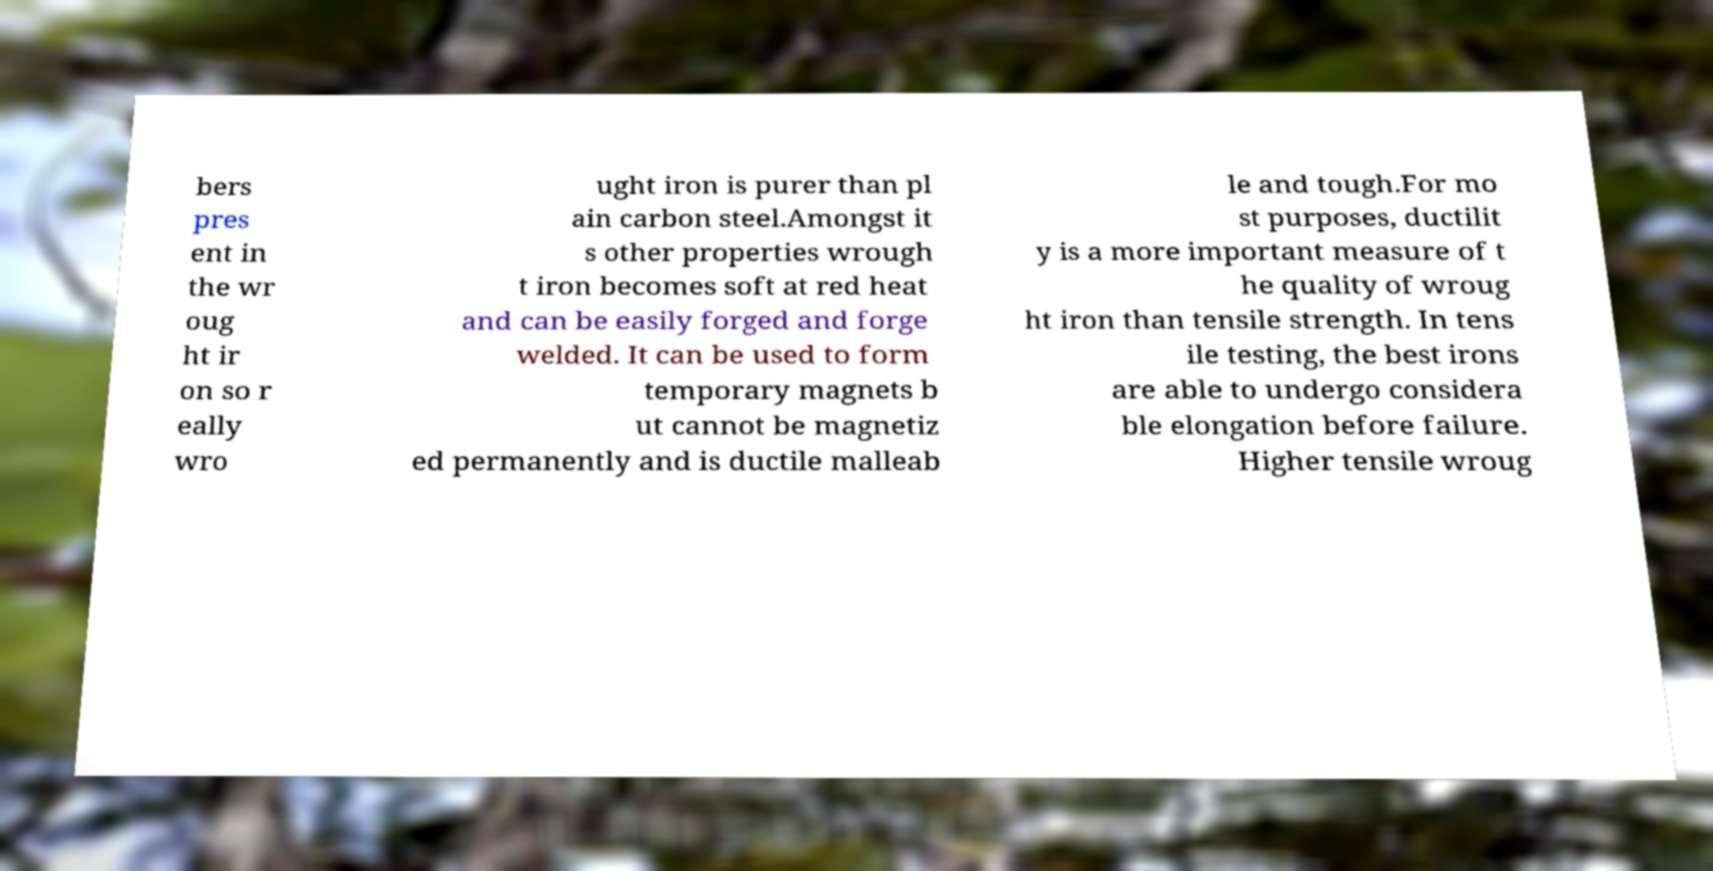What messages or text are displayed in this image? I need them in a readable, typed format. bers pres ent in the wr oug ht ir on so r eally wro ught iron is purer than pl ain carbon steel.Amongst it s other properties wrough t iron becomes soft at red heat and can be easily forged and forge welded. It can be used to form temporary magnets b ut cannot be magnetiz ed permanently and is ductile malleab le and tough.For mo st purposes, ductilit y is a more important measure of t he quality of wroug ht iron than tensile strength. In tens ile testing, the best irons are able to undergo considera ble elongation before failure. Higher tensile wroug 